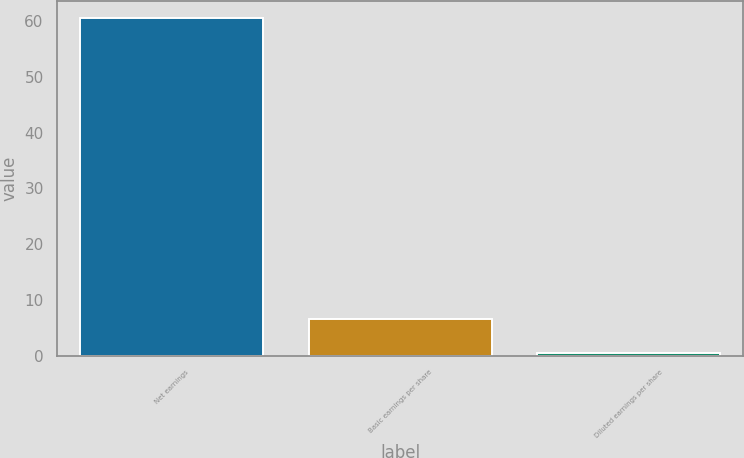<chart> <loc_0><loc_0><loc_500><loc_500><bar_chart><fcel>Net earnings<fcel>Basic earnings per share<fcel>Diluted earnings per share<nl><fcel>60.6<fcel>6.54<fcel>0.53<nl></chart> 